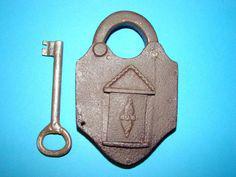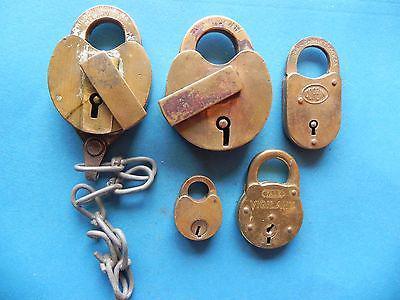The first image is the image on the left, the second image is the image on the right. For the images shown, is this caption "A key is alongside a lock, and no keys are inserted in a lock, in one image." true? Answer yes or no. Yes. The first image is the image on the left, the second image is the image on the right. Analyze the images presented: Is the assertion "There are at least two locks with their keys shown in one of the images." valid? Answer yes or no. No. The first image is the image on the left, the second image is the image on the right. Analyze the images presented: Is the assertion "There is at least 1 lock with a chain in the right image." valid? Answer yes or no. Yes. The first image is the image on the left, the second image is the image on the right. For the images shown, is this caption "There is one key and one lock in the left image." true? Answer yes or no. Yes. 